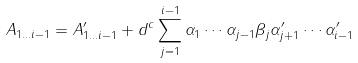Convert formula to latex. <formula><loc_0><loc_0><loc_500><loc_500>A _ { 1 \dots i - 1 } = A ^ { \prime } _ { 1 \dots i - 1 } + d ^ { c } \sum _ { j = 1 } ^ { i - 1 } \alpha _ { 1 } \cdots \alpha _ { j - 1 } \beta _ { j } \alpha _ { j + 1 } ^ { \prime } \cdots \alpha _ { i - 1 } ^ { \prime }</formula> 